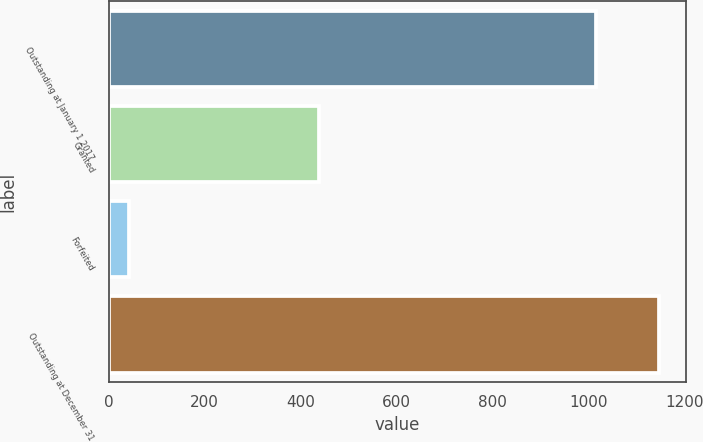Convert chart to OTSL. <chart><loc_0><loc_0><loc_500><loc_500><bar_chart><fcel>Outstanding at January 1 2017<fcel>Granted<fcel>Forfeited<fcel>Outstanding at December 31<nl><fcel>1015<fcel>439<fcel>43<fcel>1146<nl></chart> 